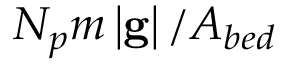<formula> <loc_0><loc_0><loc_500><loc_500>N _ { p } m \left | g \right | / A _ { b e d }</formula> 